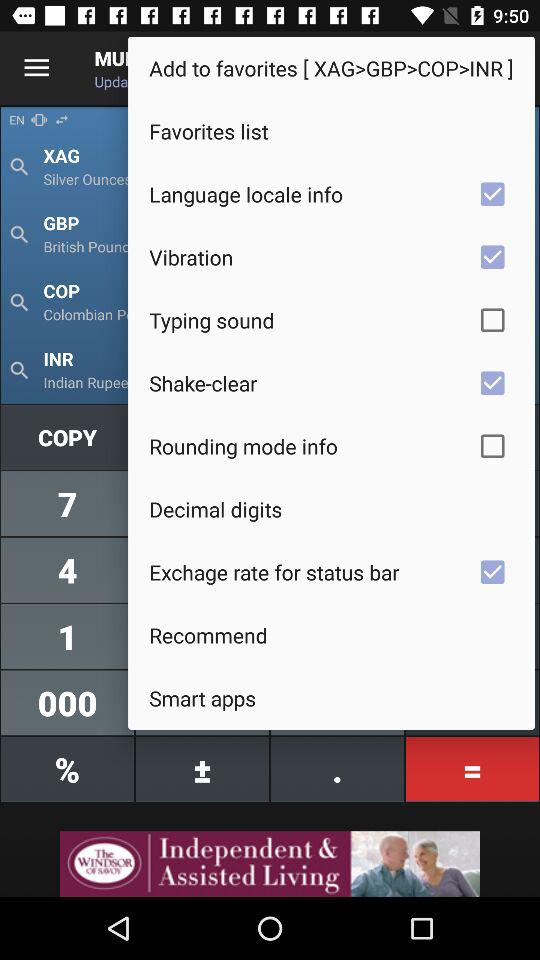How much does an ounce of silver cost?
When the provided information is insufficient, respond with <no answer>. <no answer> 